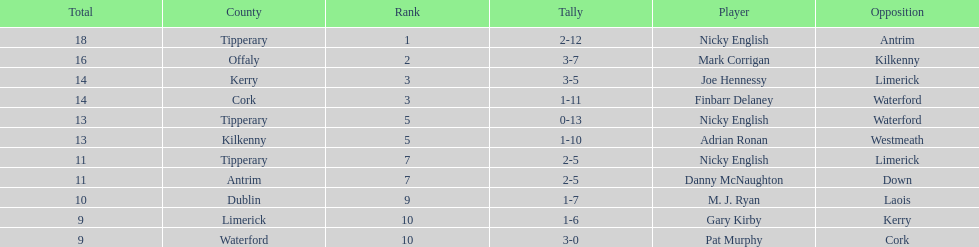What player got 10 total points in their game? M. J. Ryan. 